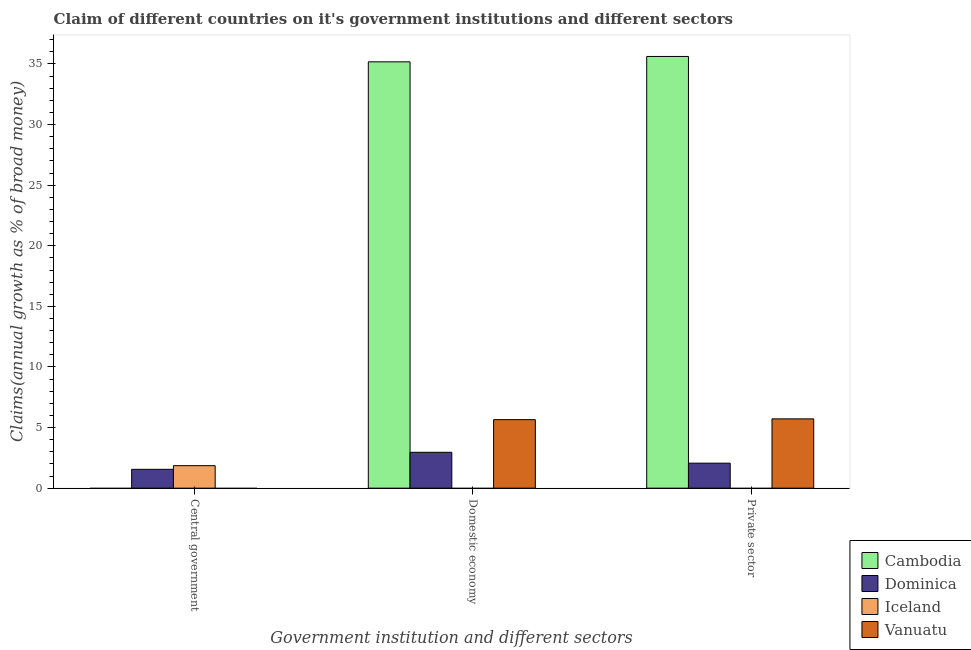How many different coloured bars are there?
Give a very brief answer. 4. How many bars are there on the 3rd tick from the right?
Ensure brevity in your answer.  2. What is the label of the 2nd group of bars from the left?
Provide a short and direct response. Domestic economy. What is the percentage of claim on the private sector in Dominica?
Offer a terse response. 2.06. Across all countries, what is the maximum percentage of claim on the private sector?
Offer a very short reply. 35.62. Across all countries, what is the minimum percentage of claim on the central government?
Your answer should be compact. 0. What is the total percentage of claim on the domestic economy in the graph?
Your response must be concise. 43.79. What is the difference between the percentage of claim on the private sector in Vanuatu and that in Dominica?
Your answer should be compact. 3.66. What is the difference between the percentage of claim on the central government in Vanuatu and the percentage of claim on the private sector in Cambodia?
Your answer should be very brief. -35.62. What is the average percentage of claim on the private sector per country?
Give a very brief answer. 10.85. What is the difference between the percentage of claim on the private sector and percentage of claim on the domestic economy in Vanuatu?
Give a very brief answer. 0.06. What is the ratio of the percentage of claim on the domestic economy in Vanuatu to that in Dominica?
Provide a succinct answer. 1.91. What is the difference between the highest and the second highest percentage of claim on the domestic economy?
Your answer should be compact. 29.52. What is the difference between the highest and the lowest percentage of claim on the private sector?
Provide a succinct answer. 35.62. How many bars are there?
Provide a succinct answer. 8. What is the difference between two consecutive major ticks on the Y-axis?
Offer a terse response. 5. How many legend labels are there?
Offer a terse response. 4. What is the title of the graph?
Your response must be concise. Claim of different countries on it's government institutions and different sectors. Does "Slovenia" appear as one of the legend labels in the graph?
Ensure brevity in your answer.  No. What is the label or title of the X-axis?
Offer a very short reply. Government institution and different sectors. What is the label or title of the Y-axis?
Your response must be concise. Claims(annual growth as % of broad money). What is the Claims(annual growth as % of broad money) of Cambodia in Central government?
Your answer should be compact. 0. What is the Claims(annual growth as % of broad money) in Dominica in Central government?
Ensure brevity in your answer.  1.55. What is the Claims(annual growth as % of broad money) in Iceland in Central government?
Offer a very short reply. 1.86. What is the Claims(annual growth as % of broad money) of Vanuatu in Central government?
Offer a terse response. 0. What is the Claims(annual growth as % of broad money) of Cambodia in Domestic economy?
Your answer should be very brief. 35.18. What is the Claims(annual growth as % of broad money) in Dominica in Domestic economy?
Ensure brevity in your answer.  2.96. What is the Claims(annual growth as % of broad money) in Vanuatu in Domestic economy?
Offer a very short reply. 5.65. What is the Claims(annual growth as % of broad money) of Cambodia in Private sector?
Offer a terse response. 35.62. What is the Claims(annual growth as % of broad money) in Dominica in Private sector?
Offer a terse response. 2.06. What is the Claims(annual growth as % of broad money) in Iceland in Private sector?
Provide a short and direct response. 0. What is the Claims(annual growth as % of broad money) in Vanuatu in Private sector?
Ensure brevity in your answer.  5.72. Across all Government institution and different sectors, what is the maximum Claims(annual growth as % of broad money) in Cambodia?
Your answer should be very brief. 35.62. Across all Government institution and different sectors, what is the maximum Claims(annual growth as % of broad money) in Dominica?
Offer a terse response. 2.96. Across all Government institution and different sectors, what is the maximum Claims(annual growth as % of broad money) in Iceland?
Make the answer very short. 1.86. Across all Government institution and different sectors, what is the maximum Claims(annual growth as % of broad money) of Vanuatu?
Provide a short and direct response. 5.72. Across all Government institution and different sectors, what is the minimum Claims(annual growth as % of broad money) in Dominica?
Provide a short and direct response. 1.55. Across all Government institution and different sectors, what is the minimum Claims(annual growth as % of broad money) in Iceland?
Make the answer very short. 0. What is the total Claims(annual growth as % of broad money) of Cambodia in the graph?
Offer a terse response. 70.8. What is the total Claims(annual growth as % of broad money) in Dominica in the graph?
Your answer should be compact. 6.58. What is the total Claims(annual growth as % of broad money) of Iceland in the graph?
Offer a very short reply. 1.86. What is the total Claims(annual growth as % of broad money) in Vanuatu in the graph?
Your answer should be compact. 11.37. What is the difference between the Claims(annual growth as % of broad money) in Dominica in Central government and that in Domestic economy?
Offer a terse response. -1.41. What is the difference between the Claims(annual growth as % of broad money) of Dominica in Central government and that in Private sector?
Offer a very short reply. -0.51. What is the difference between the Claims(annual growth as % of broad money) in Cambodia in Domestic economy and that in Private sector?
Your response must be concise. -0.44. What is the difference between the Claims(annual growth as % of broad money) in Dominica in Domestic economy and that in Private sector?
Ensure brevity in your answer.  0.9. What is the difference between the Claims(annual growth as % of broad money) of Vanuatu in Domestic economy and that in Private sector?
Your answer should be very brief. -0.06. What is the difference between the Claims(annual growth as % of broad money) in Dominica in Central government and the Claims(annual growth as % of broad money) in Vanuatu in Domestic economy?
Offer a very short reply. -4.1. What is the difference between the Claims(annual growth as % of broad money) in Iceland in Central government and the Claims(annual growth as % of broad money) in Vanuatu in Domestic economy?
Your answer should be compact. -3.8. What is the difference between the Claims(annual growth as % of broad money) in Dominica in Central government and the Claims(annual growth as % of broad money) in Vanuatu in Private sector?
Provide a succinct answer. -4.16. What is the difference between the Claims(annual growth as % of broad money) in Iceland in Central government and the Claims(annual growth as % of broad money) in Vanuatu in Private sector?
Provide a succinct answer. -3.86. What is the difference between the Claims(annual growth as % of broad money) of Cambodia in Domestic economy and the Claims(annual growth as % of broad money) of Dominica in Private sector?
Your answer should be very brief. 33.12. What is the difference between the Claims(annual growth as % of broad money) in Cambodia in Domestic economy and the Claims(annual growth as % of broad money) in Vanuatu in Private sector?
Your answer should be very brief. 29.46. What is the difference between the Claims(annual growth as % of broad money) of Dominica in Domestic economy and the Claims(annual growth as % of broad money) of Vanuatu in Private sector?
Provide a short and direct response. -2.76. What is the average Claims(annual growth as % of broad money) of Cambodia per Government institution and different sectors?
Ensure brevity in your answer.  23.6. What is the average Claims(annual growth as % of broad money) of Dominica per Government institution and different sectors?
Give a very brief answer. 2.19. What is the average Claims(annual growth as % of broad money) of Iceland per Government institution and different sectors?
Offer a very short reply. 0.62. What is the average Claims(annual growth as % of broad money) of Vanuatu per Government institution and different sectors?
Provide a succinct answer. 3.79. What is the difference between the Claims(annual growth as % of broad money) of Dominica and Claims(annual growth as % of broad money) of Iceland in Central government?
Offer a terse response. -0.3. What is the difference between the Claims(annual growth as % of broad money) in Cambodia and Claims(annual growth as % of broad money) in Dominica in Domestic economy?
Provide a short and direct response. 32.22. What is the difference between the Claims(annual growth as % of broad money) in Cambodia and Claims(annual growth as % of broad money) in Vanuatu in Domestic economy?
Make the answer very short. 29.52. What is the difference between the Claims(annual growth as % of broad money) of Dominica and Claims(annual growth as % of broad money) of Vanuatu in Domestic economy?
Your answer should be compact. -2.69. What is the difference between the Claims(annual growth as % of broad money) in Cambodia and Claims(annual growth as % of broad money) in Dominica in Private sector?
Offer a terse response. 33.56. What is the difference between the Claims(annual growth as % of broad money) of Cambodia and Claims(annual growth as % of broad money) of Vanuatu in Private sector?
Your answer should be very brief. 29.9. What is the difference between the Claims(annual growth as % of broad money) of Dominica and Claims(annual growth as % of broad money) of Vanuatu in Private sector?
Ensure brevity in your answer.  -3.66. What is the ratio of the Claims(annual growth as % of broad money) in Dominica in Central government to that in Domestic economy?
Provide a short and direct response. 0.52. What is the ratio of the Claims(annual growth as % of broad money) of Dominica in Central government to that in Private sector?
Your answer should be compact. 0.75. What is the ratio of the Claims(annual growth as % of broad money) of Cambodia in Domestic economy to that in Private sector?
Offer a terse response. 0.99. What is the ratio of the Claims(annual growth as % of broad money) in Dominica in Domestic economy to that in Private sector?
Your response must be concise. 1.44. What is the ratio of the Claims(annual growth as % of broad money) in Vanuatu in Domestic economy to that in Private sector?
Keep it short and to the point. 0.99. What is the difference between the highest and the second highest Claims(annual growth as % of broad money) of Dominica?
Provide a succinct answer. 0.9. What is the difference between the highest and the lowest Claims(annual growth as % of broad money) of Cambodia?
Offer a terse response. 35.62. What is the difference between the highest and the lowest Claims(annual growth as % of broad money) in Dominica?
Your answer should be very brief. 1.41. What is the difference between the highest and the lowest Claims(annual growth as % of broad money) of Iceland?
Offer a terse response. 1.86. What is the difference between the highest and the lowest Claims(annual growth as % of broad money) in Vanuatu?
Keep it short and to the point. 5.72. 